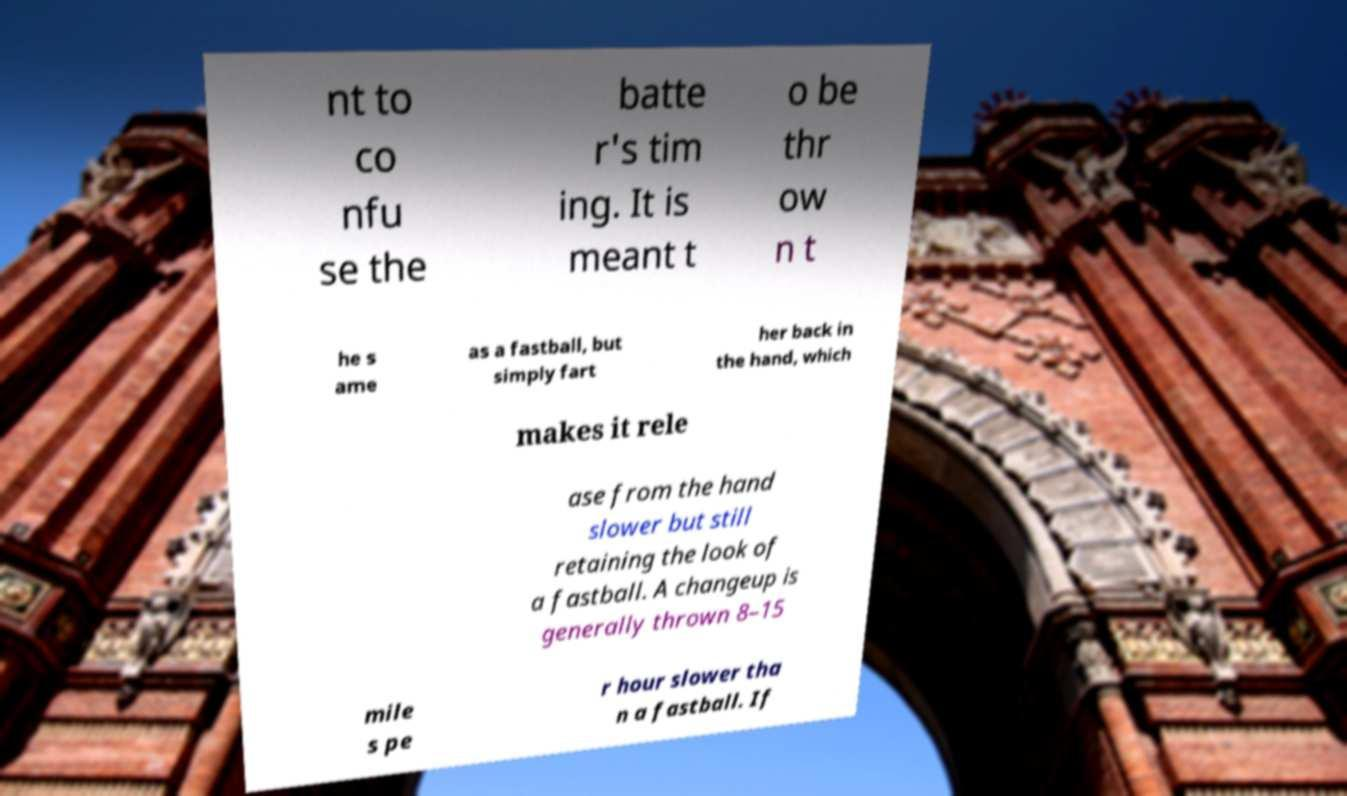Can you read and provide the text displayed in the image?This photo seems to have some interesting text. Can you extract and type it out for me? nt to co nfu se the batte r's tim ing. It is meant t o be thr ow n t he s ame as a fastball, but simply fart her back in the hand, which makes it rele ase from the hand slower but still retaining the look of a fastball. A changeup is generally thrown 8–15 mile s pe r hour slower tha n a fastball. If 